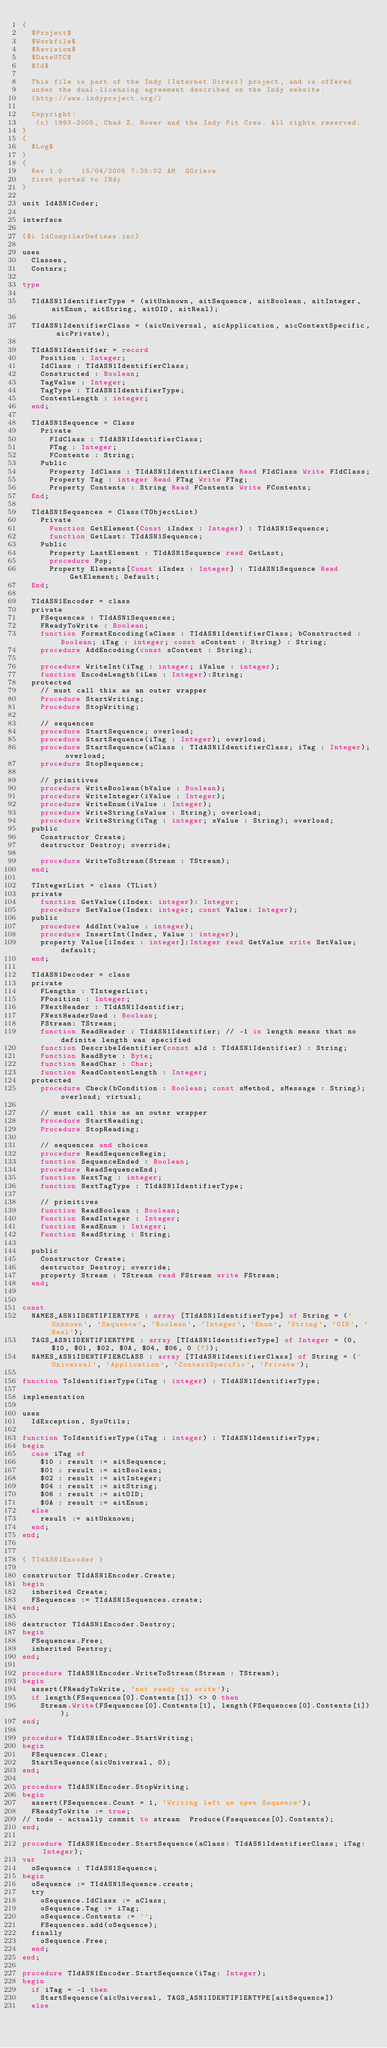Convert code to text. <code><loc_0><loc_0><loc_500><loc_500><_Pascal_>{
  $Project$
  $Workfile$
  $Revision$
  $DateUTC$
  $Id$

  This file is part of the Indy (Internet Direct) project, and is offered
  under the dual-licensing agreement described on the Indy website.
  (http://www.indyproject.org/)

  Copyright:
   (c) 1993-2005, Chad Z. Hower and the Indy Pit Crew. All rights reserved.
}
{
  $Log$
}
{
  Rev 1.0    15/04/2005 7:25:02 AM  GGrieve
  first ported to INdy
}

unit IdASN1Coder;

interface

{$i IdCompilerDefines.inc}

uses
  Classes,
  Contnrs;

type

  TIdASN1IdentifierType = (aitUnknown, aitSequence, aitBoolean, aitInteger, aitEnum, aitString, aitOID, aitReal);

  TIdASN1IdentifierClass = (aicUniversal, aicApplication, aicContextSpecific, aicPrivate);

  TIdASN1Identifier = record
    Position : Integer;
    IdClass : TIdASN1IdentifierClass;
    Constructed : Boolean;
    TagValue : Integer;
    TagType : TIdASN1IdentifierType;
    ContentLength : integer;
  end;

  TIdASN1Sequence = Class
    Private
      FIdClass : TIdASN1IdentifierClass;
      FTag : Integer;
      FContents : String;
    Public
      Property IdClass : TIdASN1IdentifierClass Read FIdClass Write FIdClass;
      Property Tag : integer Read FTag Write FTag;
      Property Contents : String Read FContents Write FContents;
  End;

  TIdASN1Sequences = Class(TObjectList)
    Private
      Function GetElement(Const iIndex : Integer) : TIdASN1Sequence;
      function GetLast: TIdASN1Sequence;
    Public
      Property LastElement : TIdASN1Sequence read GetLast;
      procedure Pop;
      Property Elements[Const iIndex : Integer] : TIdASN1Sequence Read GetElement; Default;
  End;

  TIdASN1Encoder = class
  private
    FSequences : TIdASN1Sequences;
    FReadyToWrite : Boolean;
    function FormatEncoding(aClass : TIdASN1IdentifierClass; bConstructed : Boolean; iTag : integer; const sContent : String) : String;
    procedure AddEncoding(const sContent : String);

    procedure WriteInt(iTag : integer; iValue : integer);
    function EncodeLength(iLen : Integer):String;
  protected
    // must call this as an outer wrapper
    Procedure StartWriting;
    Procedure StopWriting;

    // sequences
    procedure StartSequence; overload;
    procedure StartSequence(iTag : Integer); overload;
    procedure StartSequence(aClass : TIdASN1IdentifierClass; iTag : Integer); overload;
    procedure StopSequence;

    // primitives
    procedure WriteBoolean(bValue : Boolean);
    procedure WriteInteger(iValue : Integer);
    procedure WriteEnum(iValue : Integer);
    procedure WriteString(sValue : String); overload;
    procedure WriteString(iTag : integer; sValue : String); overload;
  public
    Constructor Create;
    destructor Destroy; override;

    procedure WriteToStream(Stream : TStream);
  end;

  TIntegerList = class (TList)
  private
    function GetValue(iIndex: integer): Integer;
    procedure SetValue(Index: integer; const Value: Integer);
  public
    procedure AddInt(value : integer);
    procedure InsertInt(Index, Value : integer);
    property Value[iIndex : integer]:Integer read GetValue write SetValue; default;
  end;

  TIdASN1Decoder = class
  private
    FLengths : TIntegerList;
    FPosition : Integer;
    FNextHeader : TIdASN1Identifier;
    FNextHeaderUsed : Boolean;
    FStream: TStream;
    function ReadHeader : TIdASN1Identifier; // -1 in length means that no definite length was specified
    function DescribeIdentifier(const aId : TIdASN1Identifier) : String;
    Function ReadByte : Byte;
    function ReadChar : Char;
    function ReadContentLength : Integer;
  protected
    procedure Check(bCondition : Boolean; const sMethod, sMessage : String); overload; virtual;

    // must call this as an outer wrapper
    Procedure StartReading;
    Procedure StopReading;

    // sequences and choices
    procedure ReadSequenceBegin;
    function SequenceEnded : Boolean;
    procedure ReadSequenceEnd;
    function NextTag : integer;
    function NextTagType : TIdASN1IdentifierType;

    // primitives
    function ReadBoolean : Boolean;
    Function ReadInteger : Integer;
    function ReadEnum : Integer;
    Function ReadString : String;

  public
    Constructor Create;
    destructor Destroy; override;
    property Stream : TStream read FStream write FStream;
  end;


const
  NAMES_ASN1IDENTIFIERTYPE : array [TIdASN1IdentifierType] of String = ('Unknown', 'Sequence', 'Boolean', 'Integer', 'Enum', 'String', 'OID', 'Real');
  TAGS_ASN1IDENTIFIERTYPE : array [TIdASN1IdentifierType] of Integer = (0, $10, $01, $02, $0A, $04, $06, 0 {?});
  NAMES_ASN1IDENTIFIERCLASS : array [TIdASN1IdentifierClass] of String = ('Universal', 'Application', 'ContextSpecific', 'Private');

function ToIdentifierType(iTag : integer) : TIdASN1IdentifierType;

implementation

uses
  IdException, SysUtils;

function ToIdentifierType(iTag : integer) : TIdASN1IdentifierType;
begin
  case iTag of
    $10 : result := aitSequence;
    $01 : result := aitBoolean;
    $02 : result := aitInteger;
    $04 : result := aitString;
    $06 : result := aitOID;
    $0A : result := aitEnum;
  else
    result := aitUnknown;
  end;
end;


{ TIdASN1Encoder }

constructor TIdASN1Encoder.Create;
begin
  inherited Create;
  FSequences := TIdASN1Sequences.create;
end;

destructor TIdASN1Encoder.Destroy;
begin
  FSequences.Free;
  inherited Destroy;
end;

procedure TIdASN1Encoder.WriteToStream(Stream : TStream);
begin
  assert(FReadyToWrite, 'not ready to write');
  if length(FSequences[0].Contents[1]) <> 0 then
    Stream.Write(FSequences[0].Contents[1], length(FSequences[0].Contents[1]));
end;

procedure TIdASN1Encoder.StartWriting;
begin
  FSequences.Clear;
  StartSequence(aicUniversal, 0);
end;

procedure TIdASN1Encoder.StopWriting;
begin
  assert(FSequences.Count = 1, 'Writing left an open Sequence');
  FReadyToWrite := true;
// todo - actually commit to stream  Produce(Fsequences[0].Contents);
end;

procedure TIdASN1Encoder.StartSequence(aClass: TIdASN1IdentifierClass; iTag: Integer);
var
  oSequence : TIdASN1Sequence;
begin
  oSequence := TIdASN1Sequence.create;
  try
    oSequence.IdClass := aClass;
    oSequence.Tag := iTag;
    oSequence.Contents := '';
    FSequences.add(oSequence);
  finally
    oSequence.Free;
  end;
end;

procedure TIdASN1Encoder.StartSequence(iTag: Integer);
begin
  if iTag = -1 then
    StartSequence(aicUniversal, TAGS_ASN1IDENTIFIERTYPE[aitSequence])
  else</code> 